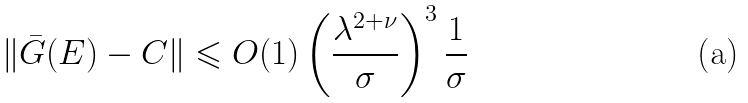Convert formula to latex. <formula><loc_0><loc_0><loc_500><loc_500>\| \bar { G } ( E ) - C \| \leqslant O ( 1 ) \left ( \frac { \lambda ^ { 2 + \nu } } { \sigma } \right ) ^ { 3 } \frac { 1 } { \sigma }</formula> 